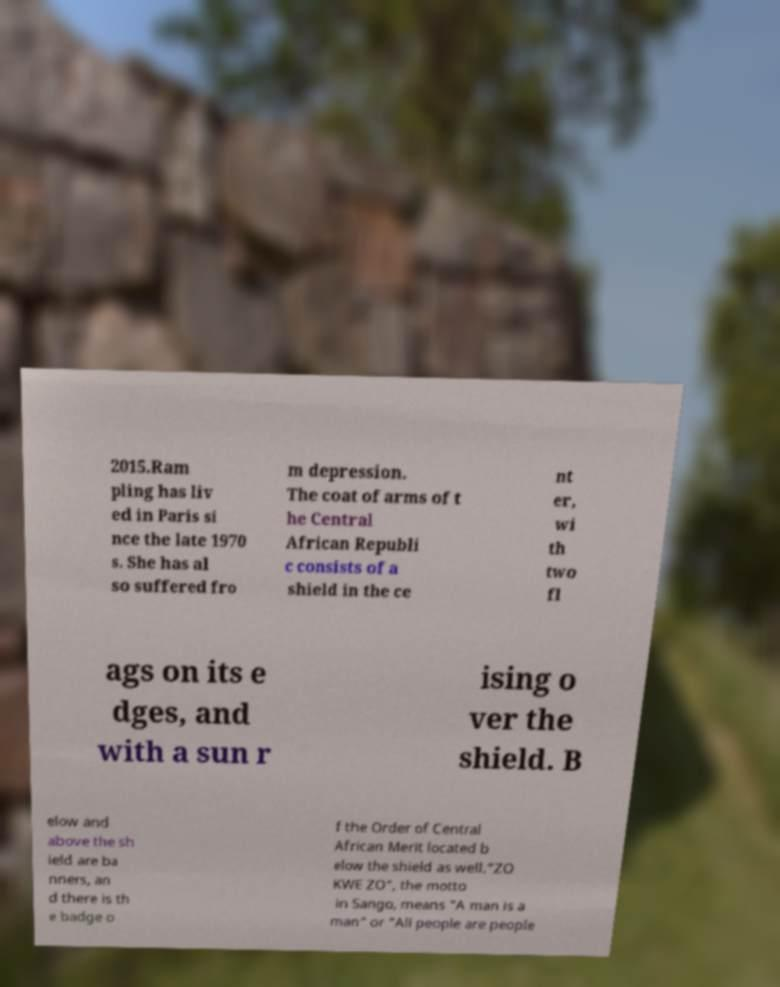I need the written content from this picture converted into text. Can you do that? 2015.Ram pling has liv ed in Paris si nce the late 1970 s. She has al so suffered fro m depression. The coat of arms of t he Central African Republi c consists of a shield in the ce nt er, wi th two fl ags on its e dges, and with a sun r ising o ver the shield. B elow and above the sh ield are ba nners, an d there is th e badge o f the Order of Central African Merit located b elow the shield as well."ZO KWE ZO", the motto in Sango, means "A man is a man" or "All people are people 